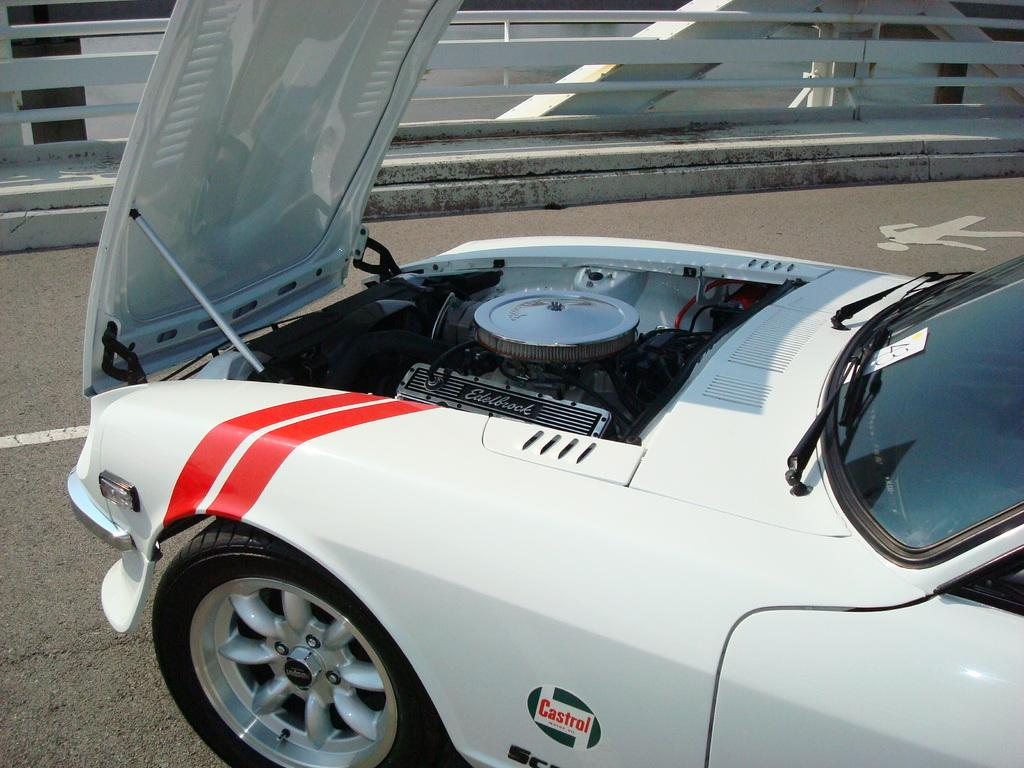What is the main subject in the foreground of the picture? There is a car in the foreground of the picture. What color is the car? The car is white. Where is the car located? The car is on the road. What can be seen in the center of the picture? There are railings, a footpath, and an iron frame in the center of the picture. How many cows are grazing in the field next to the car in the image? There is no field or cows present in the image; it features a car on the road with railings, a footpath, and an iron frame in the center. 